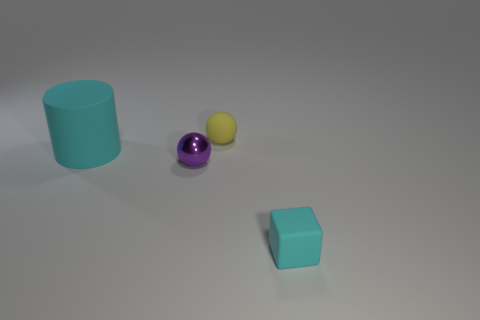Is there any other thing that has the same size as the cyan matte cylinder?
Provide a succinct answer. No. There is a big matte object; how many cyan matte things are to the right of it?
Provide a succinct answer. 1. Is the small cube made of the same material as the cyan thing that is on the left side of the tiny cyan thing?
Provide a short and direct response. Yes. Is there a block that has the same size as the purple ball?
Ensure brevity in your answer.  Yes. Is the number of big cylinders to the right of the small metal thing the same as the number of large cyan rubber objects?
Give a very brief answer. No. How big is the cyan cylinder?
Ensure brevity in your answer.  Large. There is a cyan thing that is on the left side of the cyan matte block; what number of large rubber objects are on the left side of it?
Offer a very short reply. 0. There is a thing that is behind the purple object and to the left of the yellow matte object; what shape is it?
Your response must be concise. Cylinder. How many matte cylinders are the same color as the matte ball?
Ensure brevity in your answer.  0. There is a cyan matte thing that is in front of the cyan matte object behind the purple sphere; are there any small things behind it?
Provide a short and direct response. Yes. 